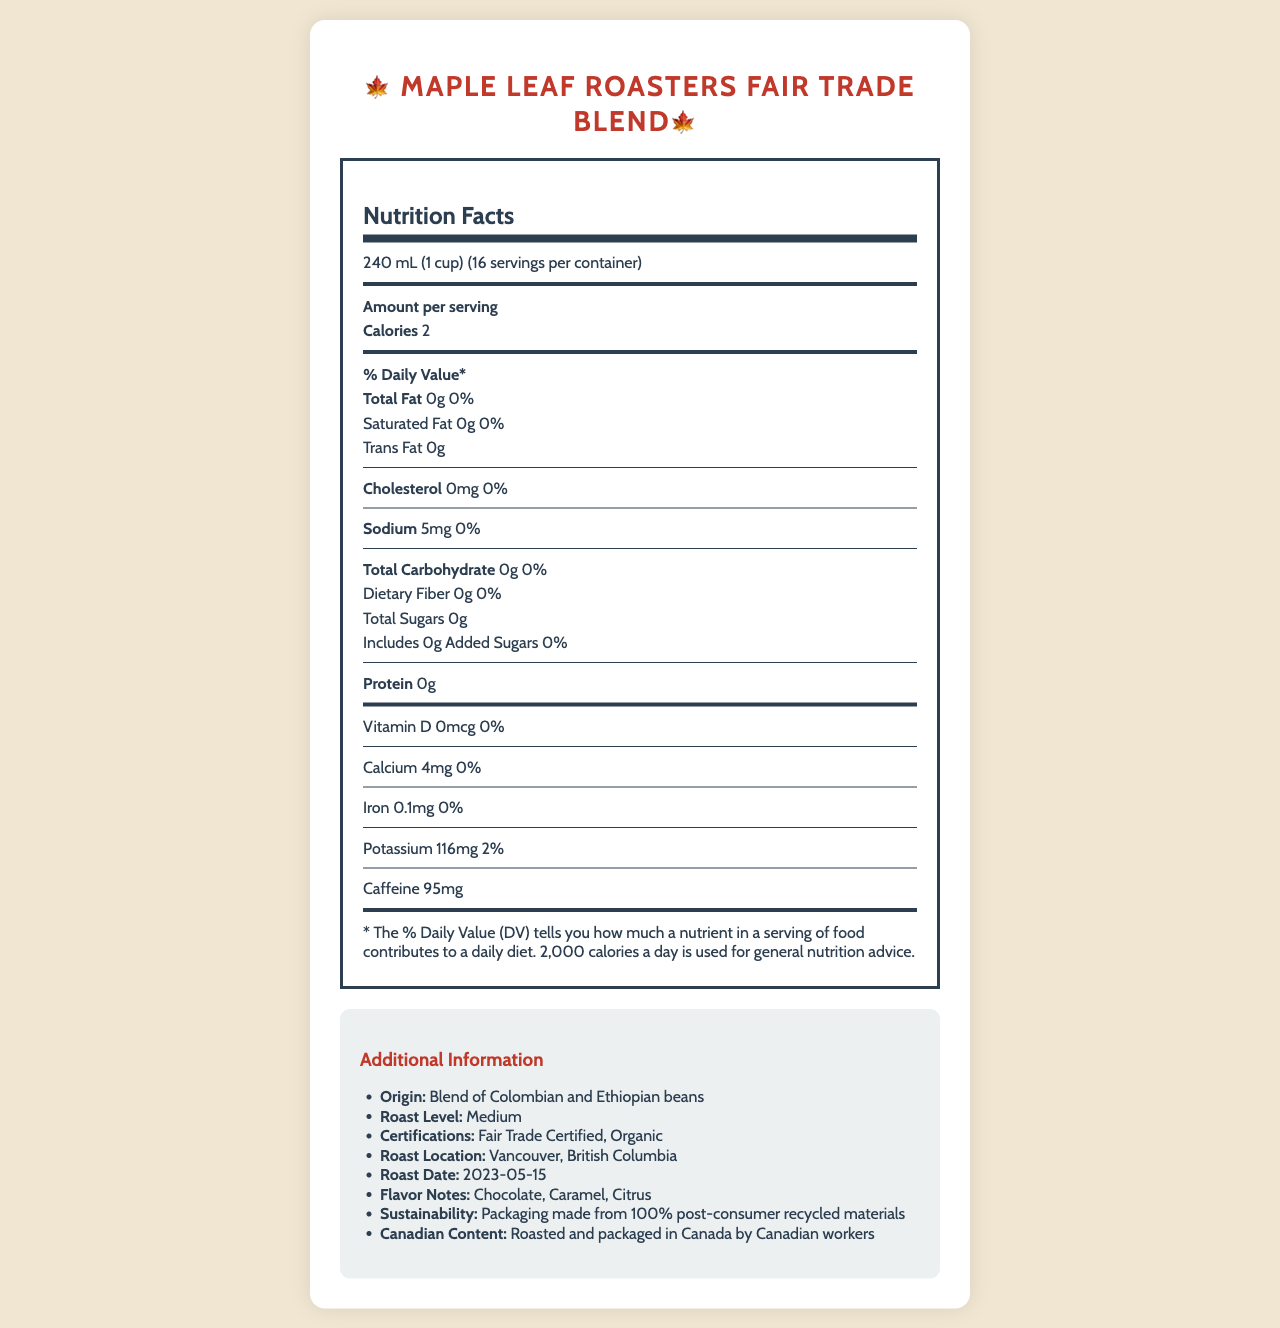what is the serving size for the Maple Leaf Roasters Fair Trade Blend? The serving size is explicitly stated as "240 mL (1 cup)" on the nutrition label.
Answer: 240 mL (1 cup) how many servings are there per container? The label indicates that there are "16 servings per container."
Answer: 16 how many calories are there per serving? The label indicates that each serving contains "2" calories.
Answer: 2 what is the roast level of the coffee? The additional information section mentions that the roast level is "Medium."
Answer: Medium does the coffee contain any added sugars? The label lists "0g" for added sugars, indicating that there are no added sugars.
Answer: No what certifications does the Maple Leaf Roasters Fair Trade Blend have? A. Fair Trade Certified B. Organic C. Non-GMO D. Both A and B The additional information specifies that the certifications are "Fair Trade Certified, Organic."
Answer: D. Both A and B how much caffeine does each serving contain? A. 80mg B. 95mg C. 100mg The nutrition facts list "Caffeine 95mg" per serving.
Answer: B. 95mg is the coffee packaging eco-friendly? The additional information mentions "Packaging made from 100% post-consumer recycled materials," implying it is eco-friendly.
Answer: Yes how much calcium is in one serving? The nutrition facts indicate that each serving contains "4mg" of calcium.
Answer: 4mg is there any sodium in the maple leaf roasters fair trade blend? The label indicates that there is "5mg" of sodium per serving.
Answer: Yes where is the coffee roasted and packaged? The additional information states that the coffee is roasted and packaged in "Vancouver, British Columbia."
Answer: Vancouver, British Columbia what is the flavor profile of this coffee? The additional information specifies the flavor notes as "Chocolate, Caramel, Citrus."
Answer: Chocolate, Caramel, Citrus summarize the main idea of the document. The document serves the purpose of informing customers about the nutritional aspects of the coffee and its various certifications and attributes. It highlights the local and sustainable efforts involved in its production.
Answer: The document provides detailed nutrition facts and additional information about the Maple Leaf Roasters Fair Trade Blend, a locally-roasted Canadian coffee. It includes nutritional values per serving, certifications, flavor notes, and sustainability information, emphasizing its fair trade and organic certifications as well as its packaging made from recycled materials. when was the coffee roasted? The additional information lists the roast date as "2023-05-15."
Answer: 2023-05-15 how much potassium does each serving contain? A. 100mg B. 110mg C. 116mg D. 120mg The nutrition facts state "Potassium 116mg" per serving.
Answer: C. 116mg is the coffee blend Canadian? The additional information section mentions "Roasted and packaged in Canada by Canadian workers."
Answer: Yes what origin beans are used in this coffee blend? The additional information notes that it is a "Blend of Colombian and Ethiopian beans."
Answer: Blend of Colombian and Ethiopian beans what is the amount of dietary fiber in each serving? The nutrition facts state that there is "0g" of dietary fiber per serving.
Answer: 0g how many grams of protein are in one serving? The label indicates that there are "0g" of protein per serving.
Answer: 0g is the document informative about the production process? The document provides nutritional information and some details about certifications and origins but lacks detailed information about the specific production process.
Answer: Not enough information how much iron does each serving contain? The nutrition facts list "Iron 0.1mg" per serving.
Answer: 0.1mg 